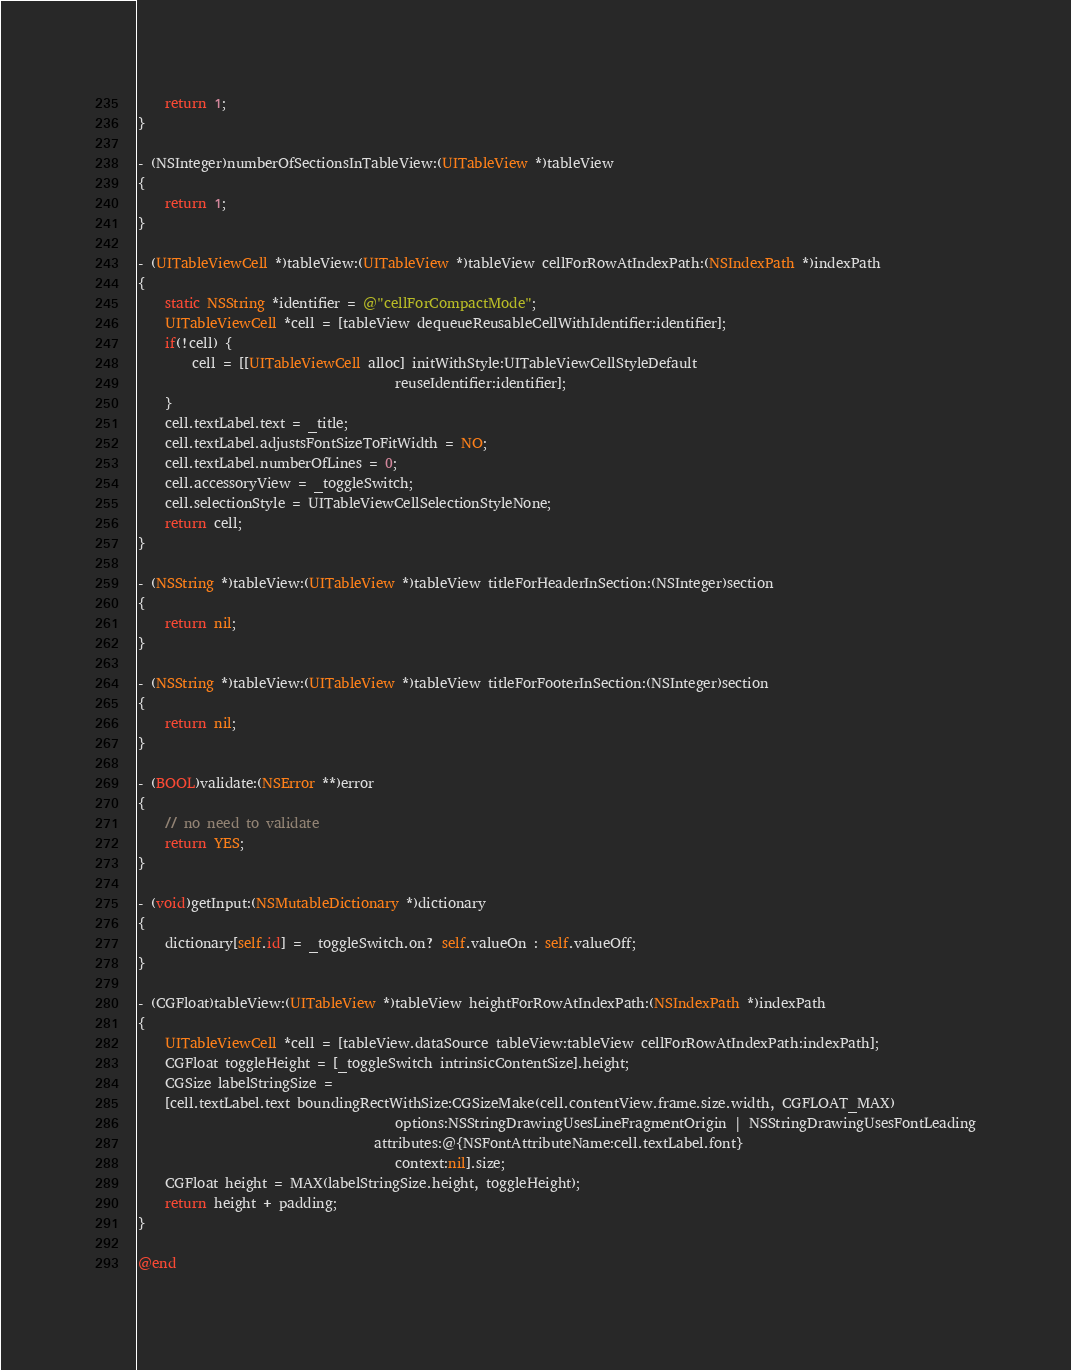<code> <loc_0><loc_0><loc_500><loc_500><_ObjectiveC_>    return 1;
}

- (NSInteger)numberOfSectionsInTableView:(UITableView *)tableView
{
    return 1;
}

- (UITableViewCell *)tableView:(UITableView *)tableView cellForRowAtIndexPath:(NSIndexPath *)indexPath
{
    static NSString *identifier = @"cellForCompactMode";
    UITableViewCell *cell = [tableView dequeueReusableCellWithIdentifier:identifier];
    if(!cell) {
        cell = [[UITableViewCell alloc] initWithStyle:UITableViewCellStyleDefault
                                      reuseIdentifier:identifier];
    }
    cell.textLabel.text = _title;
    cell.textLabel.adjustsFontSizeToFitWidth = NO;
    cell.textLabel.numberOfLines = 0;
    cell.accessoryView = _toggleSwitch;
    cell.selectionStyle = UITableViewCellSelectionStyleNone;
    return cell;
}

- (NSString *)tableView:(UITableView *)tableView titleForHeaderInSection:(NSInteger)section
{
    return nil;
}

- (NSString *)tableView:(UITableView *)tableView titleForFooterInSection:(NSInteger)section
{
    return nil;
}

- (BOOL)validate:(NSError **)error
{
    // no need to validate
    return YES;
}

- (void)getInput:(NSMutableDictionary *)dictionary
{
    dictionary[self.id] = _toggleSwitch.on? self.valueOn : self.valueOff;
}

- (CGFloat)tableView:(UITableView *)tableView heightForRowAtIndexPath:(NSIndexPath *)indexPath
{
    UITableViewCell *cell = [tableView.dataSource tableView:tableView cellForRowAtIndexPath:indexPath];   
    CGFloat toggleHeight = [_toggleSwitch intrinsicContentSize].height;
    CGSize labelStringSize =
    [cell.textLabel.text boundingRectWithSize:CGSizeMake(cell.contentView.frame.size.width, CGFLOAT_MAX)
                                      options:NSStringDrawingUsesLineFragmentOrigin | NSStringDrawingUsesFontLeading
                                   attributes:@{NSFontAttributeName:cell.textLabel.font}
                                      context:nil].size;
    CGFloat height = MAX(labelStringSize.height, toggleHeight);
    return height + padding;
}

@end
</code> 